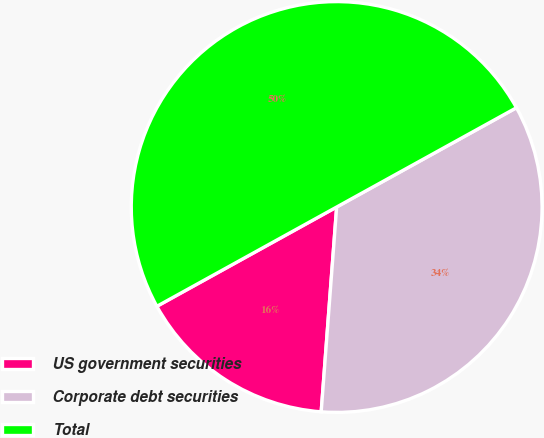<chart> <loc_0><loc_0><loc_500><loc_500><pie_chart><fcel>US government securities<fcel>Corporate debt securities<fcel>Total<nl><fcel>15.77%<fcel>34.23%<fcel>50.0%<nl></chart> 